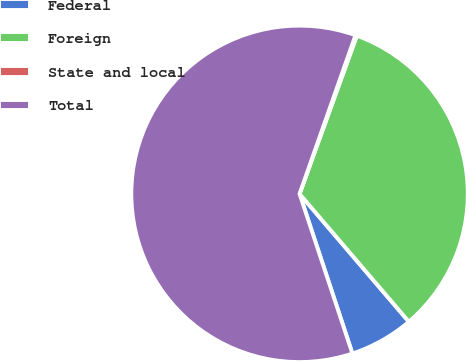<chart> <loc_0><loc_0><loc_500><loc_500><pie_chart><fcel>Federal<fcel>Foreign<fcel>State and local<fcel>Total<nl><fcel>6.17%<fcel>33.21%<fcel>0.14%<fcel>60.48%<nl></chart> 